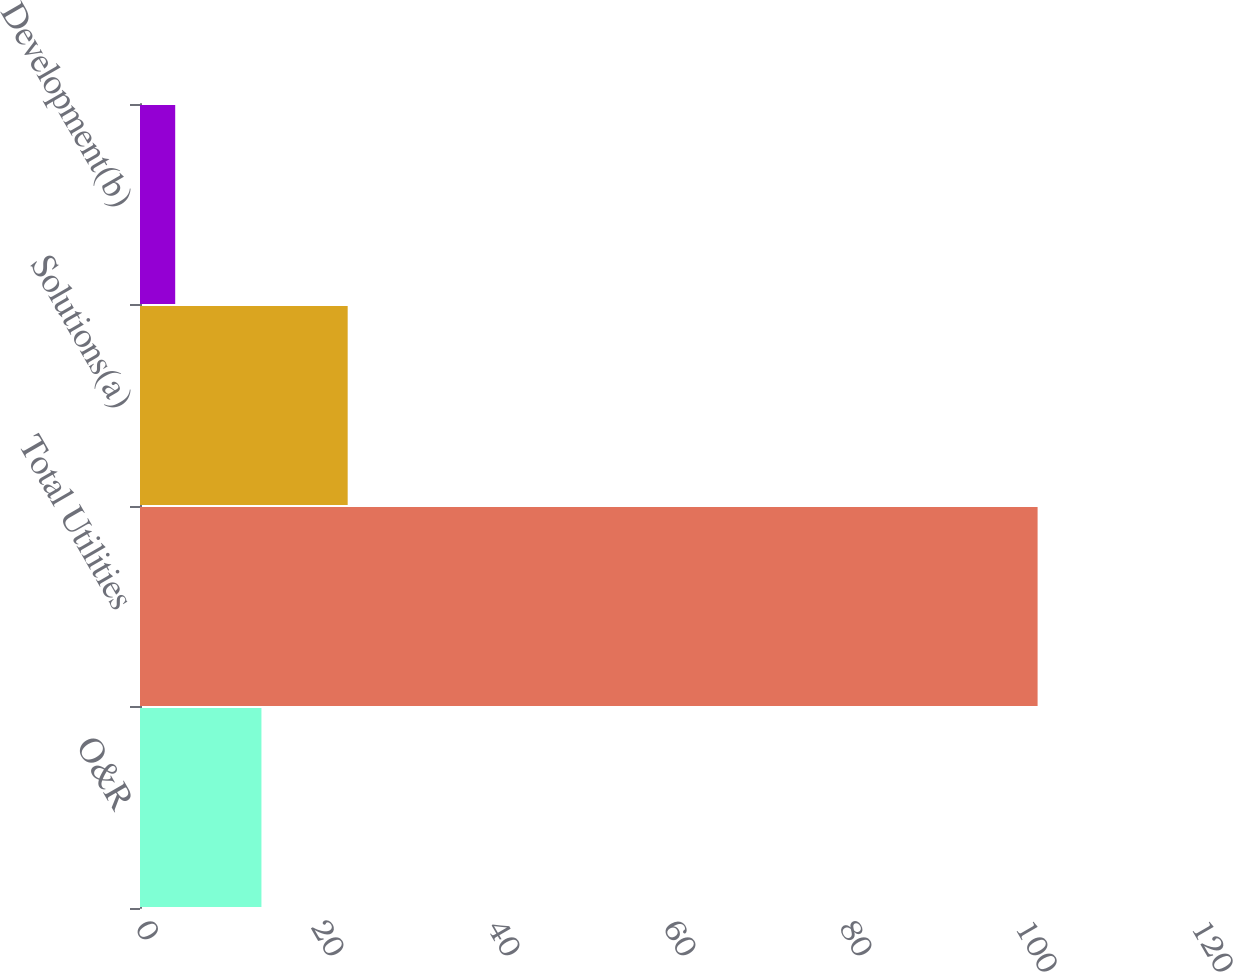Convert chart to OTSL. <chart><loc_0><loc_0><loc_500><loc_500><bar_chart><fcel>O&R<fcel>Total Utilities<fcel>Solutions(a)<fcel>Development(b)<nl><fcel>13.8<fcel>102<fcel>23.6<fcel>4<nl></chart> 